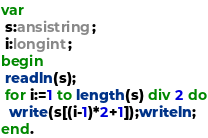<code> <loc_0><loc_0><loc_500><loc_500><_Pascal_>var
 s:ansistring;
 i:longint;
begin
 readln(s);
 for i:=1 to length(s) div 2 do
  write(s[(i-1)*2+1]);writeln;
end.</code> 